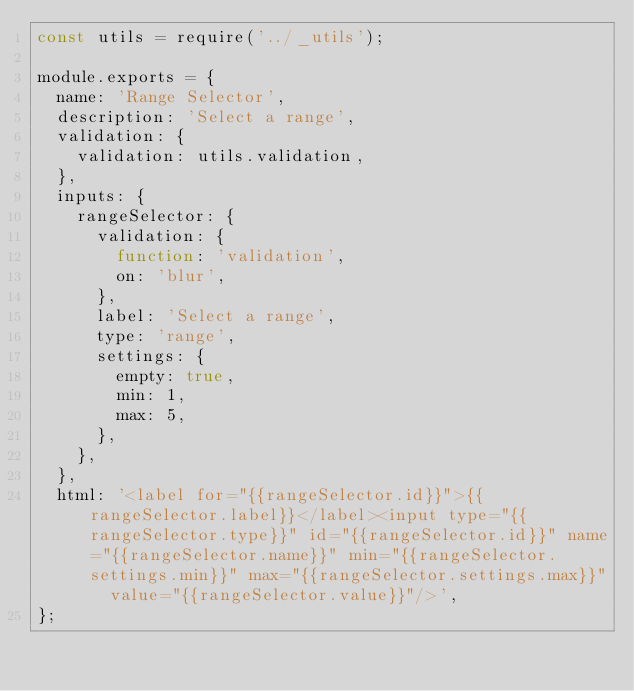Convert code to text. <code><loc_0><loc_0><loc_500><loc_500><_JavaScript_>const utils = require('../_utils');

module.exports = {
  name: 'Range Selector',
  description: 'Select a range',
  validation: {
    validation: utils.validation,
  },
  inputs: {
    rangeSelector: {
      validation: {
        function: 'validation',
        on: 'blur',
      },
      label: 'Select a range',
      type: 'range',
      settings: {
        empty: true,
        min: 1,
        max: 5,
      },
    },
  },
  html: '<label for="{{rangeSelector.id}}">{{rangeSelector.label}}</label><input type="{{rangeSelector.type}}" id="{{rangeSelector.id}}" name="{{rangeSelector.name}}" min="{{rangeSelector.settings.min}}" max="{{rangeSelector.settings.max}}"  value="{{rangeSelector.value}}"/>',
};
</code> 